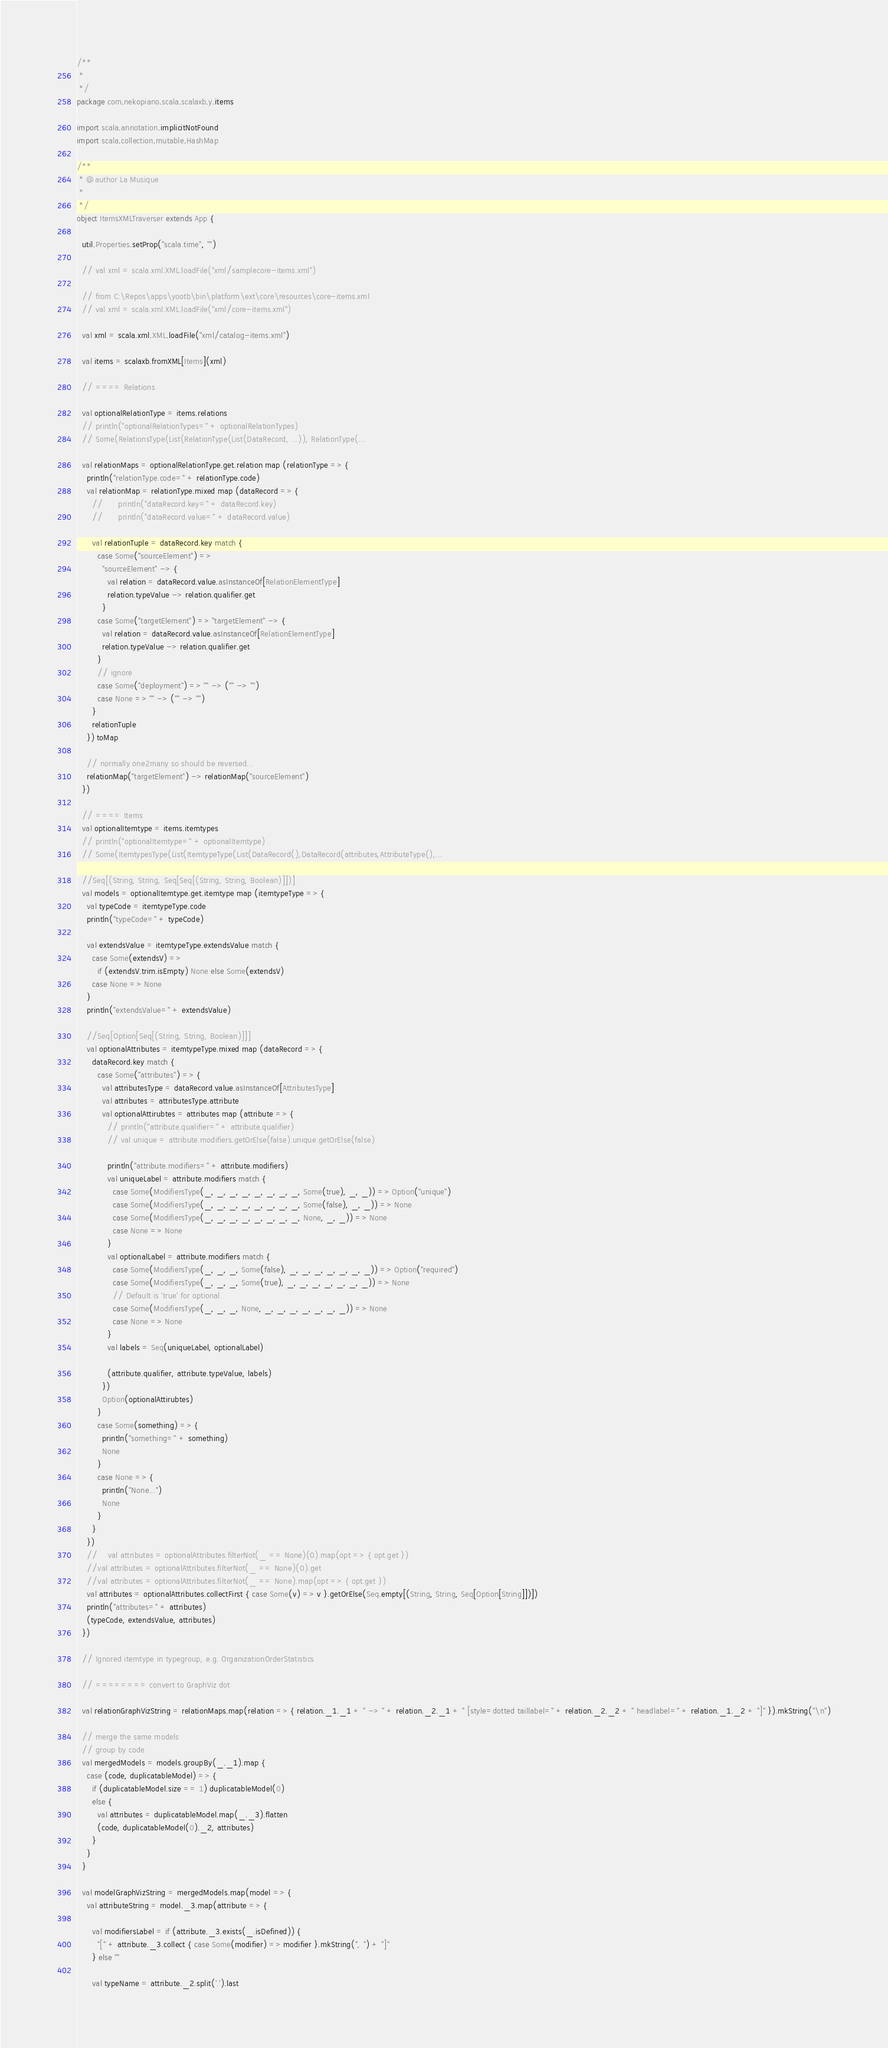<code> <loc_0><loc_0><loc_500><loc_500><_Scala_>/**
 *
 */
package com.nekopiano.scala.scalaxb.y.items

import scala.annotation.implicitNotFound
import scala.collection.mutable.HashMap

/**
 * @author La Musique
 *
 */
object ItemsXMLTraverser extends App {

  util.Properties.setProp("scala.time", "")

  // val xml = scala.xml.XML.loadFile("xml/samplecore-items.xml")

  // from C:\Repos\apps\yootb\bin\platform\ext\core\resources\core-items.xml  
  // val xml = scala.xml.XML.loadFile("xml/core-items.xml")

  val xml = scala.xml.XML.loadFile("xml/catalog-items.xml")

  val items = scalaxb.fromXML[Items](xml)

  // ==== Relations

  val optionalRelationType = items.relations
  // println("optionalRelationTypes=" + optionalRelationTypes)
  // Some(RelationsType(List(RelationType(List(DataRecord, ...)), RelationType(...

  val relationMaps = optionalRelationType.get.relation map (relationType => {
    println("relationType.code=" + relationType.code)
    val relationMap = relationType.mixed map (dataRecord => {
      //      println("dataRecord.key=" + dataRecord.key)
      //      println("dataRecord.value=" + dataRecord.value)

      val relationTuple = dataRecord.key match {
        case Some("sourceElement") =>
          "sourceElement" -> {
            val relation = dataRecord.value.asInstanceOf[RelationElementType]
            relation.typeValue -> relation.qualifier.get
          }
        case Some("targetElement") => "targetElement" -> {
          val relation = dataRecord.value.asInstanceOf[RelationElementType]
          relation.typeValue -> relation.qualifier.get
        }
        // ignore
        case Some("deployment") => "" -> ("" -> "")
        case None => "" -> ("" -> "")
      }
      relationTuple
    }) toMap

    // normally one2many so should be reversed...
    relationMap("targetElement") -> relationMap("sourceElement")
  })

  // ==== Items
  val optionalItemtype = items.itemtypes
  // println("optionalItemtype=" + optionalItemtype)
  // Some(ItemtypesType(List(ItemtypeType(List(DataRecord(),DataRecord(attributes,AttributeType(),...

  //Seq[(String, String, Seq[Seq[(String, String, Boolean)]])]
  val models = optionalItemtype.get.itemtype map (itemtypeType => {
    val typeCode = itemtypeType.code
    println("typeCode=" + typeCode)

    val extendsValue = itemtypeType.extendsValue match {
      case Some(extendsV) =>
        if (extendsV.trim.isEmpty) None else Some(extendsV)
      case None => None
    }
    println("extendsValue=" + extendsValue)

    //Seq[Option[Seq[(String, String, Boolean)]]]
    val optionalAttributes = itemtypeType.mixed map (dataRecord => {
      dataRecord.key match {
        case Some("attributes") => {
          val attributesType = dataRecord.value.asInstanceOf[AttributesType]
          val attributes = attributesType.attribute
          val optionalAttirubtes = attributes map (attribute => {
            // println("attribute.qualifier=" + attribute.qualifier)
            // val unique = attribute.modifiers.getOrElse(false).unique.getOrElse(false)

            println("attribute.modifiers=" + attribute.modifiers)
            val uniqueLabel = attribute.modifiers match {
              case Some(ModifiersType(_, _, _, _, _, _, _, _, Some(true), _, _)) => Option("unique")
              case Some(ModifiersType(_, _, _, _, _, _, _, _, Some(false), _, _)) => None
              case Some(ModifiersType(_, _, _, _, _, _, _, _, None, _, _)) => None
              case None => None
            }
            val optionalLabel = attribute.modifiers match {
              case Some(ModifiersType(_, _, _, Some(false), _, _, _, _, _, _, _)) => Option("required")
              case Some(ModifiersType(_, _, _, Some(true), _, _, _, _, _, _, _)) => None
              // Default is 'true' for optional.
              case Some(ModifiersType(_, _, _, None, _, _, _, _, _, _, _)) => None
              case None => None
            }
            val labels = Seq(uniqueLabel, optionalLabel)

            (attribute.qualifier, attribute.typeValue, labels)
          })
          Option(optionalAttirubtes)
        }
        case Some(something) => {
          println("something=" + something)
          None
        }
        case None => {
          println("None...")
          None
        }
      }
    })
    //    val attributes = optionalAttributes.filterNot(_ == None)(0).map(opt => { opt.get })
    //val attributes = optionalAttributes.filterNot(_ == None)(0).get
    //val attributes = optionalAttributes.filterNot(_ == None).map(opt => { opt.get })
    val attributes = optionalAttributes.collectFirst { case Some(v) => v }.getOrElse(Seq.empty[(String, String, Seq[Option[String]])])
    println("attributes=" + attributes)
    (typeCode, extendsValue, attributes)
  })

  // Ignored itemtype in typegroup, e.g. OrganizationOrderStatistics

  // ======== convert to GraphViz dot

  val relationGraphVizString = relationMaps.map(relation => { relation._1._1 + " -> " + relation._2._1 + " [style=dotted taillabel=" + relation._2._2 + " headlabel=" + relation._1._2 + "]" }).mkString("\n")

  // merge the same models
  // group by code
  val mergedModels = models.groupBy(_._1).map {
    case (code, duplicatableModel) => {
      if (duplicatableModel.size == 1) duplicatableModel(0)
      else {
        val attributes = duplicatableModel.map(_._3).flatten
        (code, duplicatableModel(0)._2, attributes)
      }
    }
  }

  val modelGraphVizString = mergedModels.map(model => {
    val attributeString = model._3.map(attribute => {

      val modifiersLabel = if (attribute._3.exists(_.isDefined)) {
        "[" + attribute._3.collect { case Some(modifier) => modifier }.mkString(", ") + "]"
      } else ""

      val typeName = attribute._2.split('.').last</code> 